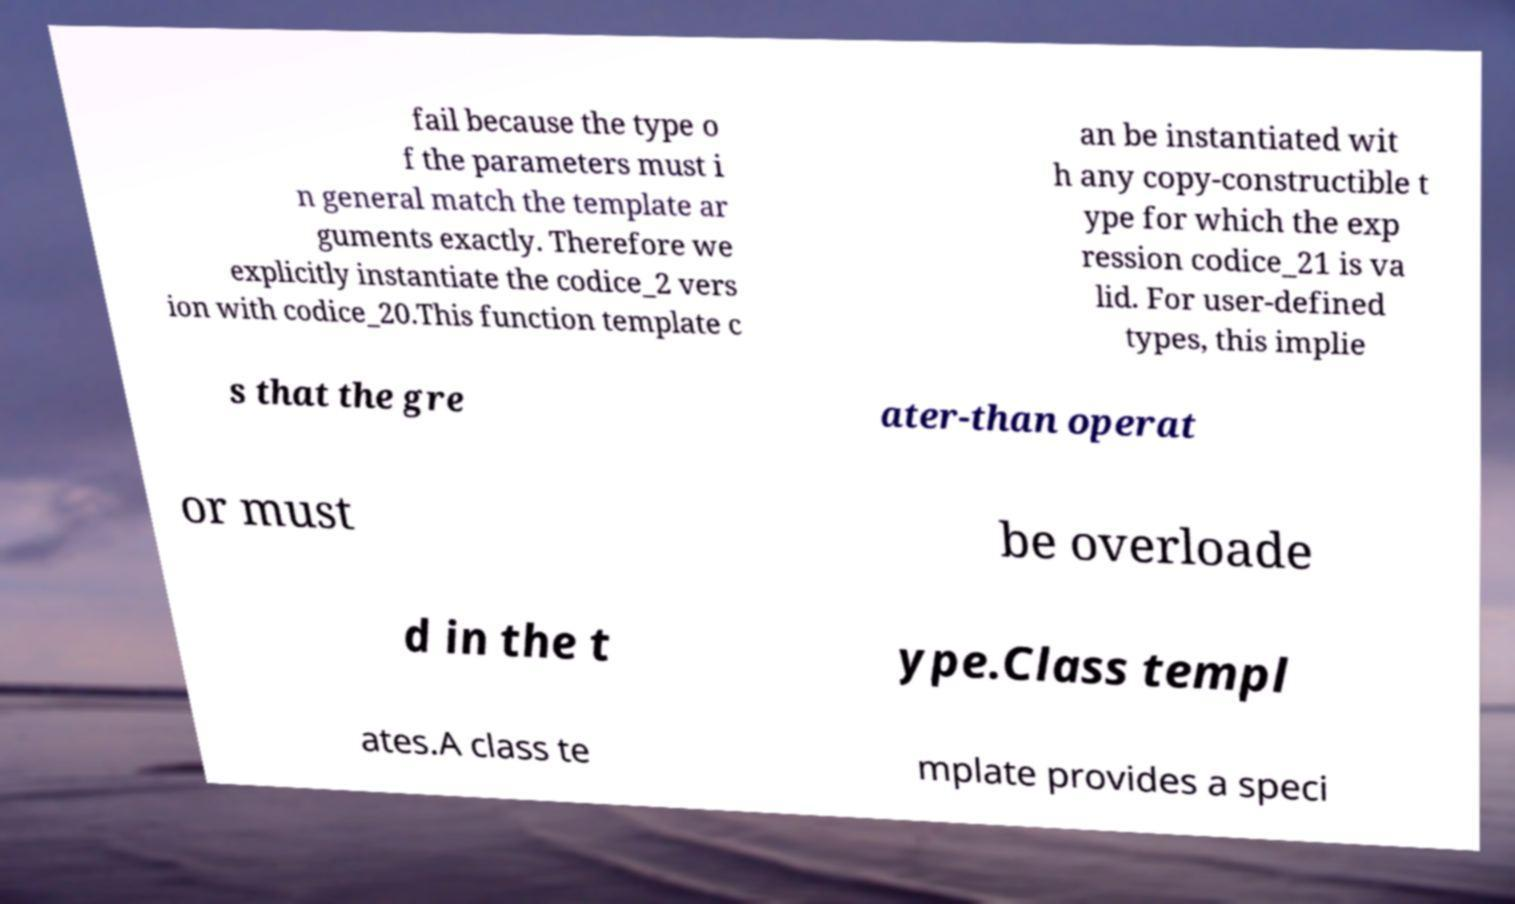Could you assist in decoding the text presented in this image and type it out clearly? fail because the type o f the parameters must i n general match the template ar guments exactly. Therefore we explicitly instantiate the codice_2 vers ion with codice_20.This function template c an be instantiated wit h any copy-constructible t ype for which the exp ression codice_21 is va lid. For user-defined types, this implie s that the gre ater-than operat or must be overloade d in the t ype.Class templ ates.A class te mplate provides a speci 